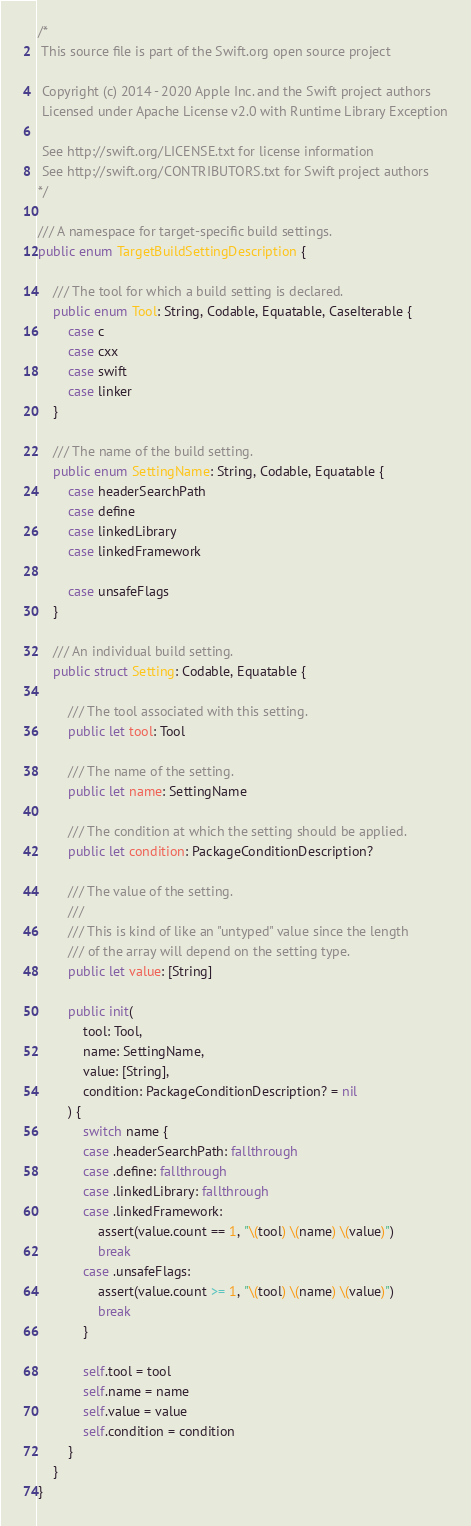<code> <loc_0><loc_0><loc_500><loc_500><_Swift_>/*
 This source file is part of the Swift.org open source project

 Copyright (c) 2014 - 2020 Apple Inc. and the Swift project authors
 Licensed under Apache License v2.0 with Runtime Library Exception

 See http://swift.org/LICENSE.txt for license information
 See http://swift.org/CONTRIBUTORS.txt for Swift project authors
*/

/// A namespace for target-specific build settings.
public enum TargetBuildSettingDescription {

    /// The tool for which a build setting is declared.
    public enum Tool: String, Codable, Equatable, CaseIterable {
        case c
        case cxx
        case swift
        case linker
    }

    /// The name of the build setting.
    public enum SettingName: String, Codable, Equatable {
        case headerSearchPath
        case define
        case linkedLibrary
        case linkedFramework

        case unsafeFlags
    }

    /// An individual build setting.
    public struct Setting: Codable, Equatable {

        /// The tool associated with this setting.
        public let tool: Tool

        /// The name of the setting.
        public let name: SettingName

        /// The condition at which the setting should be applied.
        public let condition: PackageConditionDescription?

        /// The value of the setting.
        ///
        /// This is kind of like an "untyped" value since the length
        /// of the array will depend on the setting type.
        public let value: [String]

        public init(
            tool: Tool,
            name: SettingName,
            value: [String],
            condition: PackageConditionDescription? = nil
        ) {
            switch name {
            case .headerSearchPath: fallthrough
            case .define: fallthrough
            case .linkedLibrary: fallthrough
            case .linkedFramework:
                assert(value.count == 1, "\(tool) \(name) \(value)")
                break
            case .unsafeFlags:
                assert(value.count >= 1, "\(tool) \(name) \(value)")
                break
            }

            self.tool = tool
            self.name = name
            self.value = value
            self.condition = condition
        }
    }
}
</code> 